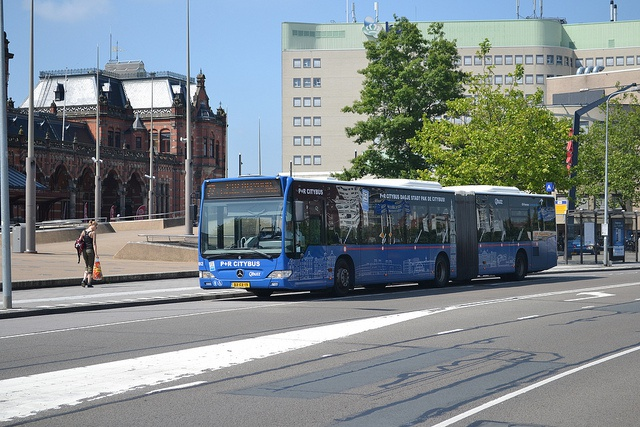Describe the objects in this image and their specific colors. I can see bus in gray, black, navy, and darkblue tones, people in gray, black, and darkgray tones, people in gray, black, and blue tones, backpack in gray, black, and maroon tones, and handbag in gray, black, maroon, and darkgray tones in this image. 